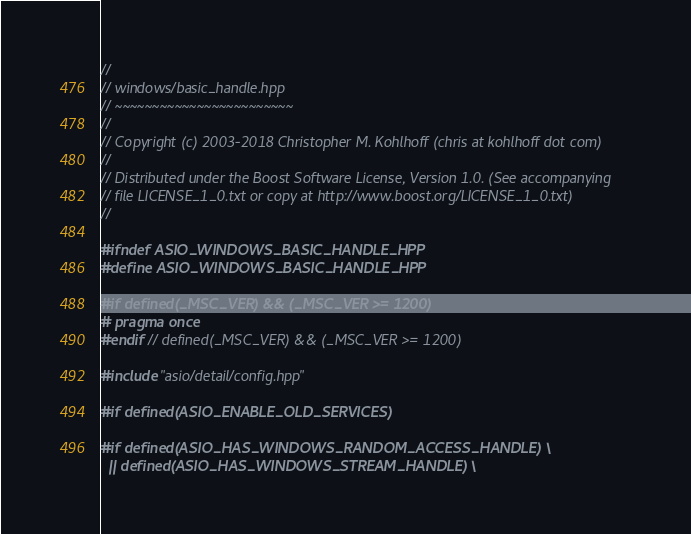Convert code to text. <code><loc_0><loc_0><loc_500><loc_500><_C++_>//
// windows/basic_handle.hpp
// ~~~~~~~~~~~~~~~~~~~~~~~~
//
// Copyright (c) 2003-2018 Christopher M. Kohlhoff (chris at kohlhoff dot com)
//
// Distributed under the Boost Software License, Version 1.0. (See accompanying
// file LICENSE_1_0.txt or copy at http://www.boost.org/LICENSE_1_0.txt)
//

#ifndef ASIO_WINDOWS_BASIC_HANDLE_HPP
#define ASIO_WINDOWS_BASIC_HANDLE_HPP

#if defined(_MSC_VER) && (_MSC_VER >= 1200)
# pragma once
#endif // defined(_MSC_VER) && (_MSC_VER >= 1200)

#include "asio/detail/config.hpp"

#if defined(ASIO_ENABLE_OLD_SERVICES)

#if defined(ASIO_HAS_WINDOWS_RANDOM_ACCESS_HANDLE) \
  || defined(ASIO_HAS_WINDOWS_STREAM_HANDLE) \</code> 